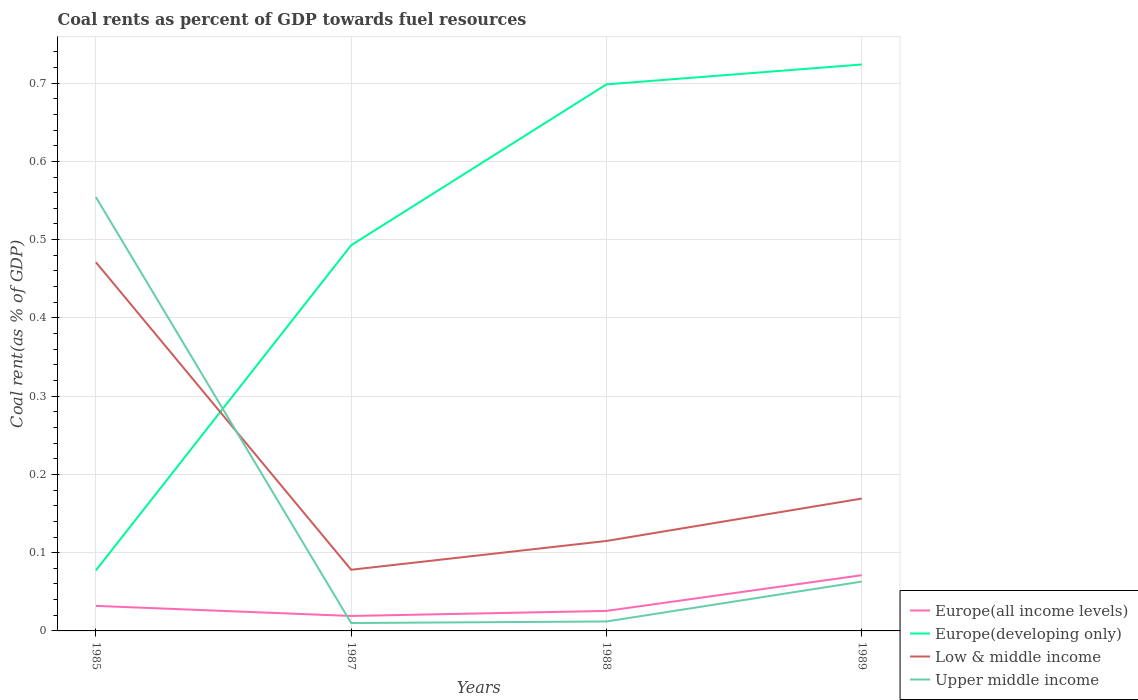Is the number of lines equal to the number of legend labels?
Keep it short and to the point. Yes. Across all years, what is the maximum coal rent in Low & middle income?
Provide a succinct answer. 0.08. In which year was the coal rent in Europe(all income levels) maximum?
Provide a short and direct response. 1987. What is the total coal rent in Europe(all income levels) in the graph?
Offer a terse response. 0.01. What is the difference between the highest and the second highest coal rent in Upper middle income?
Your answer should be compact. 0.54. What is the difference between the highest and the lowest coal rent in Upper middle income?
Make the answer very short. 1. Is the coal rent in Low & middle income strictly greater than the coal rent in Europe(all income levels) over the years?
Your response must be concise. No. How many lines are there?
Your answer should be very brief. 4. What is the difference between two consecutive major ticks on the Y-axis?
Offer a very short reply. 0.1. Does the graph contain grids?
Give a very brief answer. Yes. How are the legend labels stacked?
Keep it short and to the point. Vertical. What is the title of the graph?
Offer a terse response. Coal rents as percent of GDP towards fuel resources. Does "Brunei Darussalam" appear as one of the legend labels in the graph?
Your answer should be very brief. No. What is the label or title of the Y-axis?
Make the answer very short. Coal rent(as % of GDP). What is the Coal rent(as % of GDP) in Europe(all income levels) in 1985?
Offer a terse response. 0.03. What is the Coal rent(as % of GDP) in Europe(developing only) in 1985?
Provide a short and direct response. 0.08. What is the Coal rent(as % of GDP) in Low & middle income in 1985?
Ensure brevity in your answer.  0.47. What is the Coal rent(as % of GDP) of Upper middle income in 1985?
Offer a terse response. 0.55. What is the Coal rent(as % of GDP) of Europe(all income levels) in 1987?
Make the answer very short. 0.02. What is the Coal rent(as % of GDP) in Europe(developing only) in 1987?
Offer a terse response. 0.49. What is the Coal rent(as % of GDP) in Low & middle income in 1987?
Offer a terse response. 0.08. What is the Coal rent(as % of GDP) in Upper middle income in 1987?
Offer a terse response. 0.01. What is the Coal rent(as % of GDP) in Europe(all income levels) in 1988?
Your answer should be very brief. 0.03. What is the Coal rent(as % of GDP) in Europe(developing only) in 1988?
Provide a short and direct response. 0.7. What is the Coal rent(as % of GDP) in Low & middle income in 1988?
Offer a terse response. 0.11. What is the Coal rent(as % of GDP) of Upper middle income in 1988?
Provide a short and direct response. 0.01. What is the Coal rent(as % of GDP) of Europe(all income levels) in 1989?
Offer a terse response. 0.07. What is the Coal rent(as % of GDP) of Europe(developing only) in 1989?
Keep it short and to the point. 0.72. What is the Coal rent(as % of GDP) in Low & middle income in 1989?
Your response must be concise. 0.17. What is the Coal rent(as % of GDP) of Upper middle income in 1989?
Offer a terse response. 0.06. Across all years, what is the maximum Coal rent(as % of GDP) of Europe(all income levels)?
Provide a short and direct response. 0.07. Across all years, what is the maximum Coal rent(as % of GDP) of Europe(developing only)?
Your answer should be compact. 0.72. Across all years, what is the maximum Coal rent(as % of GDP) in Low & middle income?
Offer a very short reply. 0.47. Across all years, what is the maximum Coal rent(as % of GDP) of Upper middle income?
Ensure brevity in your answer.  0.55. Across all years, what is the minimum Coal rent(as % of GDP) of Europe(all income levels)?
Offer a terse response. 0.02. Across all years, what is the minimum Coal rent(as % of GDP) in Europe(developing only)?
Your answer should be very brief. 0.08. Across all years, what is the minimum Coal rent(as % of GDP) of Low & middle income?
Your answer should be compact. 0.08. Across all years, what is the minimum Coal rent(as % of GDP) of Upper middle income?
Give a very brief answer. 0.01. What is the total Coal rent(as % of GDP) in Europe(all income levels) in the graph?
Keep it short and to the point. 0.15. What is the total Coal rent(as % of GDP) of Europe(developing only) in the graph?
Provide a succinct answer. 1.99. What is the total Coal rent(as % of GDP) in Low & middle income in the graph?
Provide a short and direct response. 0.83. What is the total Coal rent(as % of GDP) of Upper middle income in the graph?
Provide a short and direct response. 0.64. What is the difference between the Coal rent(as % of GDP) in Europe(all income levels) in 1985 and that in 1987?
Your response must be concise. 0.01. What is the difference between the Coal rent(as % of GDP) of Europe(developing only) in 1985 and that in 1987?
Your response must be concise. -0.42. What is the difference between the Coal rent(as % of GDP) in Low & middle income in 1985 and that in 1987?
Your response must be concise. 0.39. What is the difference between the Coal rent(as % of GDP) in Upper middle income in 1985 and that in 1987?
Make the answer very short. 0.54. What is the difference between the Coal rent(as % of GDP) in Europe(all income levels) in 1985 and that in 1988?
Keep it short and to the point. 0.01. What is the difference between the Coal rent(as % of GDP) of Europe(developing only) in 1985 and that in 1988?
Give a very brief answer. -0.62. What is the difference between the Coal rent(as % of GDP) in Low & middle income in 1985 and that in 1988?
Your response must be concise. 0.36. What is the difference between the Coal rent(as % of GDP) of Upper middle income in 1985 and that in 1988?
Your answer should be compact. 0.54. What is the difference between the Coal rent(as % of GDP) in Europe(all income levels) in 1985 and that in 1989?
Your answer should be compact. -0.04. What is the difference between the Coal rent(as % of GDP) in Europe(developing only) in 1985 and that in 1989?
Your response must be concise. -0.65. What is the difference between the Coal rent(as % of GDP) in Low & middle income in 1985 and that in 1989?
Keep it short and to the point. 0.3. What is the difference between the Coal rent(as % of GDP) of Upper middle income in 1985 and that in 1989?
Your response must be concise. 0.49. What is the difference between the Coal rent(as % of GDP) of Europe(all income levels) in 1987 and that in 1988?
Provide a short and direct response. -0.01. What is the difference between the Coal rent(as % of GDP) of Europe(developing only) in 1987 and that in 1988?
Ensure brevity in your answer.  -0.21. What is the difference between the Coal rent(as % of GDP) of Low & middle income in 1987 and that in 1988?
Ensure brevity in your answer.  -0.04. What is the difference between the Coal rent(as % of GDP) in Upper middle income in 1987 and that in 1988?
Ensure brevity in your answer.  -0. What is the difference between the Coal rent(as % of GDP) of Europe(all income levels) in 1987 and that in 1989?
Your answer should be compact. -0.05. What is the difference between the Coal rent(as % of GDP) in Europe(developing only) in 1987 and that in 1989?
Your response must be concise. -0.23. What is the difference between the Coal rent(as % of GDP) of Low & middle income in 1987 and that in 1989?
Provide a short and direct response. -0.09. What is the difference between the Coal rent(as % of GDP) of Upper middle income in 1987 and that in 1989?
Your answer should be compact. -0.05. What is the difference between the Coal rent(as % of GDP) in Europe(all income levels) in 1988 and that in 1989?
Your answer should be very brief. -0.05. What is the difference between the Coal rent(as % of GDP) of Europe(developing only) in 1988 and that in 1989?
Give a very brief answer. -0.03. What is the difference between the Coal rent(as % of GDP) of Low & middle income in 1988 and that in 1989?
Your answer should be compact. -0.05. What is the difference between the Coal rent(as % of GDP) of Upper middle income in 1988 and that in 1989?
Provide a short and direct response. -0.05. What is the difference between the Coal rent(as % of GDP) in Europe(all income levels) in 1985 and the Coal rent(as % of GDP) in Europe(developing only) in 1987?
Offer a very short reply. -0.46. What is the difference between the Coal rent(as % of GDP) in Europe(all income levels) in 1985 and the Coal rent(as % of GDP) in Low & middle income in 1987?
Your response must be concise. -0.05. What is the difference between the Coal rent(as % of GDP) in Europe(all income levels) in 1985 and the Coal rent(as % of GDP) in Upper middle income in 1987?
Offer a very short reply. 0.02. What is the difference between the Coal rent(as % of GDP) of Europe(developing only) in 1985 and the Coal rent(as % of GDP) of Low & middle income in 1987?
Keep it short and to the point. -0. What is the difference between the Coal rent(as % of GDP) in Europe(developing only) in 1985 and the Coal rent(as % of GDP) in Upper middle income in 1987?
Your answer should be very brief. 0.07. What is the difference between the Coal rent(as % of GDP) of Low & middle income in 1985 and the Coal rent(as % of GDP) of Upper middle income in 1987?
Your response must be concise. 0.46. What is the difference between the Coal rent(as % of GDP) of Europe(all income levels) in 1985 and the Coal rent(as % of GDP) of Europe(developing only) in 1988?
Ensure brevity in your answer.  -0.67. What is the difference between the Coal rent(as % of GDP) in Europe(all income levels) in 1985 and the Coal rent(as % of GDP) in Low & middle income in 1988?
Provide a short and direct response. -0.08. What is the difference between the Coal rent(as % of GDP) in Europe(all income levels) in 1985 and the Coal rent(as % of GDP) in Upper middle income in 1988?
Your response must be concise. 0.02. What is the difference between the Coal rent(as % of GDP) in Europe(developing only) in 1985 and the Coal rent(as % of GDP) in Low & middle income in 1988?
Make the answer very short. -0.04. What is the difference between the Coal rent(as % of GDP) of Europe(developing only) in 1985 and the Coal rent(as % of GDP) of Upper middle income in 1988?
Offer a terse response. 0.07. What is the difference between the Coal rent(as % of GDP) in Low & middle income in 1985 and the Coal rent(as % of GDP) in Upper middle income in 1988?
Your answer should be very brief. 0.46. What is the difference between the Coal rent(as % of GDP) in Europe(all income levels) in 1985 and the Coal rent(as % of GDP) in Europe(developing only) in 1989?
Offer a very short reply. -0.69. What is the difference between the Coal rent(as % of GDP) of Europe(all income levels) in 1985 and the Coal rent(as % of GDP) of Low & middle income in 1989?
Keep it short and to the point. -0.14. What is the difference between the Coal rent(as % of GDP) of Europe(all income levels) in 1985 and the Coal rent(as % of GDP) of Upper middle income in 1989?
Offer a terse response. -0.03. What is the difference between the Coal rent(as % of GDP) in Europe(developing only) in 1985 and the Coal rent(as % of GDP) in Low & middle income in 1989?
Your response must be concise. -0.09. What is the difference between the Coal rent(as % of GDP) in Europe(developing only) in 1985 and the Coal rent(as % of GDP) in Upper middle income in 1989?
Your answer should be very brief. 0.01. What is the difference between the Coal rent(as % of GDP) in Low & middle income in 1985 and the Coal rent(as % of GDP) in Upper middle income in 1989?
Your answer should be very brief. 0.41. What is the difference between the Coal rent(as % of GDP) in Europe(all income levels) in 1987 and the Coal rent(as % of GDP) in Europe(developing only) in 1988?
Offer a very short reply. -0.68. What is the difference between the Coal rent(as % of GDP) in Europe(all income levels) in 1987 and the Coal rent(as % of GDP) in Low & middle income in 1988?
Your answer should be very brief. -0.1. What is the difference between the Coal rent(as % of GDP) in Europe(all income levels) in 1987 and the Coal rent(as % of GDP) in Upper middle income in 1988?
Provide a succinct answer. 0.01. What is the difference between the Coal rent(as % of GDP) of Europe(developing only) in 1987 and the Coal rent(as % of GDP) of Low & middle income in 1988?
Ensure brevity in your answer.  0.38. What is the difference between the Coal rent(as % of GDP) in Europe(developing only) in 1987 and the Coal rent(as % of GDP) in Upper middle income in 1988?
Offer a terse response. 0.48. What is the difference between the Coal rent(as % of GDP) in Low & middle income in 1987 and the Coal rent(as % of GDP) in Upper middle income in 1988?
Give a very brief answer. 0.07. What is the difference between the Coal rent(as % of GDP) of Europe(all income levels) in 1987 and the Coal rent(as % of GDP) of Europe(developing only) in 1989?
Offer a very short reply. -0.7. What is the difference between the Coal rent(as % of GDP) in Europe(all income levels) in 1987 and the Coal rent(as % of GDP) in Low & middle income in 1989?
Your answer should be very brief. -0.15. What is the difference between the Coal rent(as % of GDP) of Europe(all income levels) in 1987 and the Coal rent(as % of GDP) of Upper middle income in 1989?
Ensure brevity in your answer.  -0.04. What is the difference between the Coal rent(as % of GDP) of Europe(developing only) in 1987 and the Coal rent(as % of GDP) of Low & middle income in 1989?
Keep it short and to the point. 0.32. What is the difference between the Coal rent(as % of GDP) of Europe(developing only) in 1987 and the Coal rent(as % of GDP) of Upper middle income in 1989?
Keep it short and to the point. 0.43. What is the difference between the Coal rent(as % of GDP) of Low & middle income in 1987 and the Coal rent(as % of GDP) of Upper middle income in 1989?
Offer a very short reply. 0.02. What is the difference between the Coal rent(as % of GDP) in Europe(all income levels) in 1988 and the Coal rent(as % of GDP) in Europe(developing only) in 1989?
Keep it short and to the point. -0.7. What is the difference between the Coal rent(as % of GDP) in Europe(all income levels) in 1988 and the Coal rent(as % of GDP) in Low & middle income in 1989?
Provide a succinct answer. -0.14. What is the difference between the Coal rent(as % of GDP) in Europe(all income levels) in 1988 and the Coal rent(as % of GDP) in Upper middle income in 1989?
Provide a succinct answer. -0.04. What is the difference between the Coal rent(as % of GDP) in Europe(developing only) in 1988 and the Coal rent(as % of GDP) in Low & middle income in 1989?
Keep it short and to the point. 0.53. What is the difference between the Coal rent(as % of GDP) in Europe(developing only) in 1988 and the Coal rent(as % of GDP) in Upper middle income in 1989?
Give a very brief answer. 0.64. What is the difference between the Coal rent(as % of GDP) of Low & middle income in 1988 and the Coal rent(as % of GDP) of Upper middle income in 1989?
Give a very brief answer. 0.05. What is the average Coal rent(as % of GDP) in Europe(all income levels) per year?
Provide a short and direct response. 0.04. What is the average Coal rent(as % of GDP) of Europe(developing only) per year?
Offer a very short reply. 0.5. What is the average Coal rent(as % of GDP) in Low & middle income per year?
Your answer should be compact. 0.21. What is the average Coal rent(as % of GDP) in Upper middle income per year?
Offer a terse response. 0.16. In the year 1985, what is the difference between the Coal rent(as % of GDP) in Europe(all income levels) and Coal rent(as % of GDP) in Europe(developing only)?
Provide a short and direct response. -0.05. In the year 1985, what is the difference between the Coal rent(as % of GDP) of Europe(all income levels) and Coal rent(as % of GDP) of Low & middle income?
Offer a terse response. -0.44. In the year 1985, what is the difference between the Coal rent(as % of GDP) of Europe(all income levels) and Coal rent(as % of GDP) of Upper middle income?
Your answer should be compact. -0.52. In the year 1985, what is the difference between the Coal rent(as % of GDP) in Europe(developing only) and Coal rent(as % of GDP) in Low & middle income?
Your response must be concise. -0.39. In the year 1985, what is the difference between the Coal rent(as % of GDP) of Europe(developing only) and Coal rent(as % of GDP) of Upper middle income?
Give a very brief answer. -0.48. In the year 1985, what is the difference between the Coal rent(as % of GDP) of Low & middle income and Coal rent(as % of GDP) of Upper middle income?
Provide a short and direct response. -0.08. In the year 1987, what is the difference between the Coal rent(as % of GDP) of Europe(all income levels) and Coal rent(as % of GDP) of Europe(developing only)?
Offer a terse response. -0.47. In the year 1987, what is the difference between the Coal rent(as % of GDP) in Europe(all income levels) and Coal rent(as % of GDP) in Low & middle income?
Your response must be concise. -0.06. In the year 1987, what is the difference between the Coal rent(as % of GDP) of Europe(all income levels) and Coal rent(as % of GDP) of Upper middle income?
Offer a very short reply. 0.01. In the year 1987, what is the difference between the Coal rent(as % of GDP) of Europe(developing only) and Coal rent(as % of GDP) of Low & middle income?
Your response must be concise. 0.41. In the year 1987, what is the difference between the Coal rent(as % of GDP) of Europe(developing only) and Coal rent(as % of GDP) of Upper middle income?
Make the answer very short. 0.48. In the year 1987, what is the difference between the Coal rent(as % of GDP) in Low & middle income and Coal rent(as % of GDP) in Upper middle income?
Keep it short and to the point. 0.07. In the year 1988, what is the difference between the Coal rent(as % of GDP) in Europe(all income levels) and Coal rent(as % of GDP) in Europe(developing only)?
Give a very brief answer. -0.67. In the year 1988, what is the difference between the Coal rent(as % of GDP) in Europe(all income levels) and Coal rent(as % of GDP) in Low & middle income?
Ensure brevity in your answer.  -0.09. In the year 1988, what is the difference between the Coal rent(as % of GDP) in Europe(all income levels) and Coal rent(as % of GDP) in Upper middle income?
Ensure brevity in your answer.  0.01. In the year 1988, what is the difference between the Coal rent(as % of GDP) in Europe(developing only) and Coal rent(as % of GDP) in Low & middle income?
Your response must be concise. 0.58. In the year 1988, what is the difference between the Coal rent(as % of GDP) in Europe(developing only) and Coal rent(as % of GDP) in Upper middle income?
Offer a very short reply. 0.69. In the year 1988, what is the difference between the Coal rent(as % of GDP) of Low & middle income and Coal rent(as % of GDP) of Upper middle income?
Your answer should be very brief. 0.1. In the year 1989, what is the difference between the Coal rent(as % of GDP) of Europe(all income levels) and Coal rent(as % of GDP) of Europe(developing only)?
Provide a succinct answer. -0.65. In the year 1989, what is the difference between the Coal rent(as % of GDP) in Europe(all income levels) and Coal rent(as % of GDP) in Low & middle income?
Give a very brief answer. -0.1. In the year 1989, what is the difference between the Coal rent(as % of GDP) in Europe(all income levels) and Coal rent(as % of GDP) in Upper middle income?
Your answer should be compact. 0.01. In the year 1989, what is the difference between the Coal rent(as % of GDP) in Europe(developing only) and Coal rent(as % of GDP) in Low & middle income?
Offer a terse response. 0.55. In the year 1989, what is the difference between the Coal rent(as % of GDP) of Europe(developing only) and Coal rent(as % of GDP) of Upper middle income?
Your answer should be compact. 0.66. In the year 1989, what is the difference between the Coal rent(as % of GDP) of Low & middle income and Coal rent(as % of GDP) of Upper middle income?
Keep it short and to the point. 0.11. What is the ratio of the Coal rent(as % of GDP) of Europe(all income levels) in 1985 to that in 1987?
Your answer should be very brief. 1.67. What is the ratio of the Coal rent(as % of GDP) of Europe(developing only) in 1985 to that in 1987?
Your answer should be very brief. 0.16. What is the ratio of the Coal rent(as % of GDP) of Low & middle income in 1985 to that in 1987?
Offer a terse response. 6.03. What is the ratio of the Coal rent(as % of GDP) of Upper middle income in 1985 to that in 1987?
Provide a succinct answer. 55.01. What is the ratio of the Coal rent(as % of GDP) of Europe(all income levels) in 1985 to that in 1988?
Your answer should be very brief. 1.25. What is the ratio of the Coal rent(as % of GDP) in Europe(developing only) in 1985 to that in 1988?
Your answer should be very brief. 0.11. What is the ratio of the Coal rent(as % of GDP) in Low & middle income in 1985 to that in 1988?
Your response must be concise. 4.1. What is the ratio of the Coal rent(as % of GDP) in Upper middle income in 1985 to that in 1988?
Provide a succinct answer. 45.96. What is the ratio of the Coal rent(as % of GDP) of Europe(all income levels) in 1985 to that in 1989?
Provide a succinct answer. 0.45. What is the ratio of the Coal rent(as % of GDP) in Europe(developing only) in 1985 to that in 1989?
Give a very brief answer. 0.11. What is the ratio of the Coal rent(as % of GDP) in Low & middle income in 1985 to that in 1989?
Your answer should be very brief. 2.79. What is the ratio of the Coal rent(as % of GDP) of Upper middle income in 1985 to that in 1989?
Ensure brevity in your answer.  8.8. What is the ratio of the Coal rent(as % of GDP) in Europe(all income levels) in 1987 to that in 1988?
Your answer should be very brief. 0.75. What is the ratio of the Coal rent(as % of GDP) of Europe(developing only) in 1987 to that in 1988?
Keep it short and to the point. 0.71. What is the ratio of the Coal rent(as % of GDP) in Low & middle income in 1987 to that in 1988?
Offer a terse response. 0.68. What is the ratio of the Coal rent(as % of GDP) in Upper middle income in 1987 to that in 1988?
Provide a short and direct response. 0.84. What is the ratio of the Coal rent(as % of GDP) of Europe(all income levels) in 1987 to that in 1989?
Offer a very short reply. 0.27. What is the ratio of the Coal rent(as % of GDP) in Europe(developing only) in 1987 to that in 1989?
Offer a terse response. 0.68. What is the ratio of the Coal rent(as % of GDP) in Low & middle income in 1987 to that in 1989?
Offer a very short reply. 0.46. What is the ratio of the Coal rent(as % of GDP) of Upper middle income in 1987 to that in 1989?
Keep it short and to the point. 0.16. What is the ratio of the Coal rent(as % of GDP) in Europe(all income levels) in 1988 to that in 1989?
Your response must be concise. 0.36. What is the ratio of the Coal rent(as % of GDP) in Europe(developing only) in 1988 to that in 1989?
Your response must be concise. 0.96. What is the ratio of the Coal rent(as % of GDP) in Low & middle income in 1988 to that in 1989?
Your answer should be very brief. 0.68. What is the ratio of the Coal rent(as % of GDP) of Upper middle income in 1988 to that in 1989?
Make the answer very short. 0.19. What is the difference between the highest and the second highest Coal rent(as % of GDP) in Europe(all income levels)?
Keep it short and to the point. 0.04. What is the difference between the highest and the second highest Coal rent(as % of GDP) in Europe(developing only)?
Keep it short and to the point. 0.03. What is the difference between the highest and the second highest Coal rent(as % of GDP) in Low & middle income?
Offer a very short reply. 0.3. What is the difference between the highest and the second highest Coal rent(as % of GDP) in Upper middle income?
Provide a short and direct response. 0.49. What is the difference between the highest and the lowest Coal rent(as % of GDP) in Europe(all income levels)?
Your response must be concise. 0.05. What is the difference between the highest and the lowest Coal rent(as % of GDP) in Europe(developing only)?
Provide a short and direct response. 0.65. What is the difference between the highest and the lowest Coal rent(as % of GDP) in Low & middle income?
Keep it short and to the point. 0.39. What is the difference between the highest and the lowest Coal rent(as % of GDP) in Upper middle income?
Give a very brief answer. 0.54. 